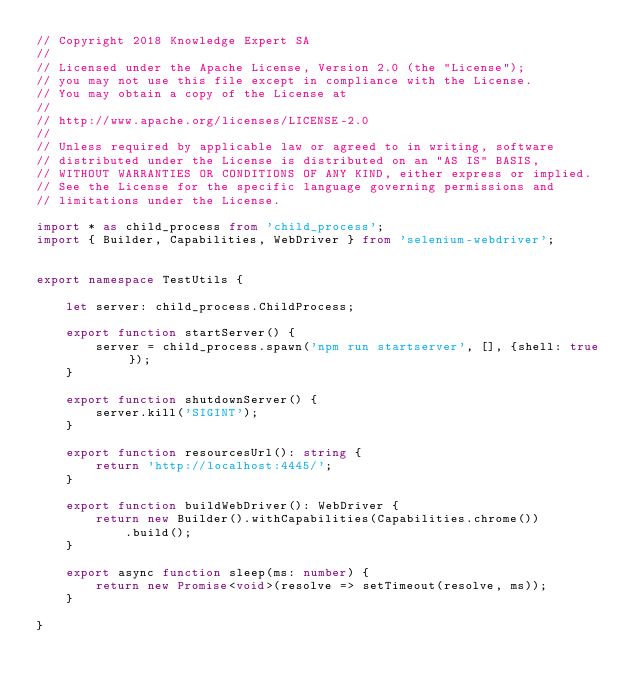Convert code to text. <code><loc_0><loc_0><loc_500><loc_500><_TypeScript_>// Copyright 2018 Knowledge Expert SA
//
// Licensed under the Apache License, Version 2.0 (the "License");
// you may not use this file except in compliance with the License.
// You may obtain a copy of the License at
//
// http://www.apache.org/licenses/LICENSE-2.0
//
// Unless required by applicable law or agreed to in writing, software
// distributed under the License is distributed on an "AS IS" BASIS,
// WITHOUT WARRANTIES OR CONDITIONS OF ANY KIND, either express or implied.
// See the License for the specific language governing permissions and
// limitations under the License.

import * as child_process from 'child_process';
import { Builder, Capabilities, WebDriver } from 'selenium-webdriver';


export namespace TestUtils {

    let server: child_process.ChildProcess;

    export function startServer() {
        server = child_process.spawn('npm run startserver', [], {shell: true});
    }

    export function shutdownServer() {
        server.kill('SIGINT');
    }

    export function resourcesUrl(): string {
        return 'http://localhost:4445/';
    }

    export function buildWebDriver(): WebDriver {
        return new Builder().withCapabilities(Capabilities.chrome())
            .build();
    }

    export async function sleep(ms: number) {
        return new Promise<void>(resolve => setTimeout(resolve, ms));
    }

}
</code> 